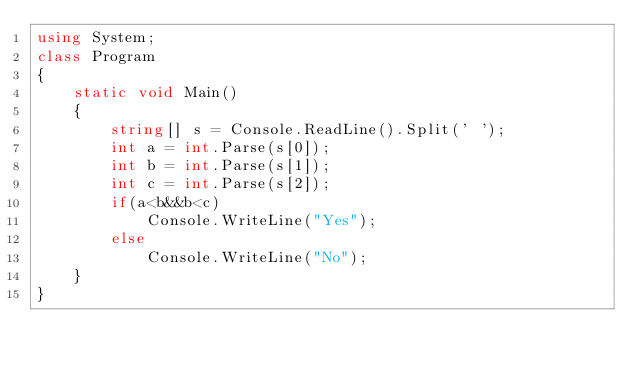<code> <loc_0><loc_0><loc_500><loc_500><_C#_>using System;
class Program
{
    static void Main()
    {
        string[] s = Console.ReadLine().Split(' ');
        int a = int.Parse(s[0]);
        int b = int.Parse(s[1]);
        int c = int.Parse(s[2]);
        if(a<b&&b<c)
            Console.WriteLine("Yes");
        else
            Console.WriteLine("No");
    }
}</code> 